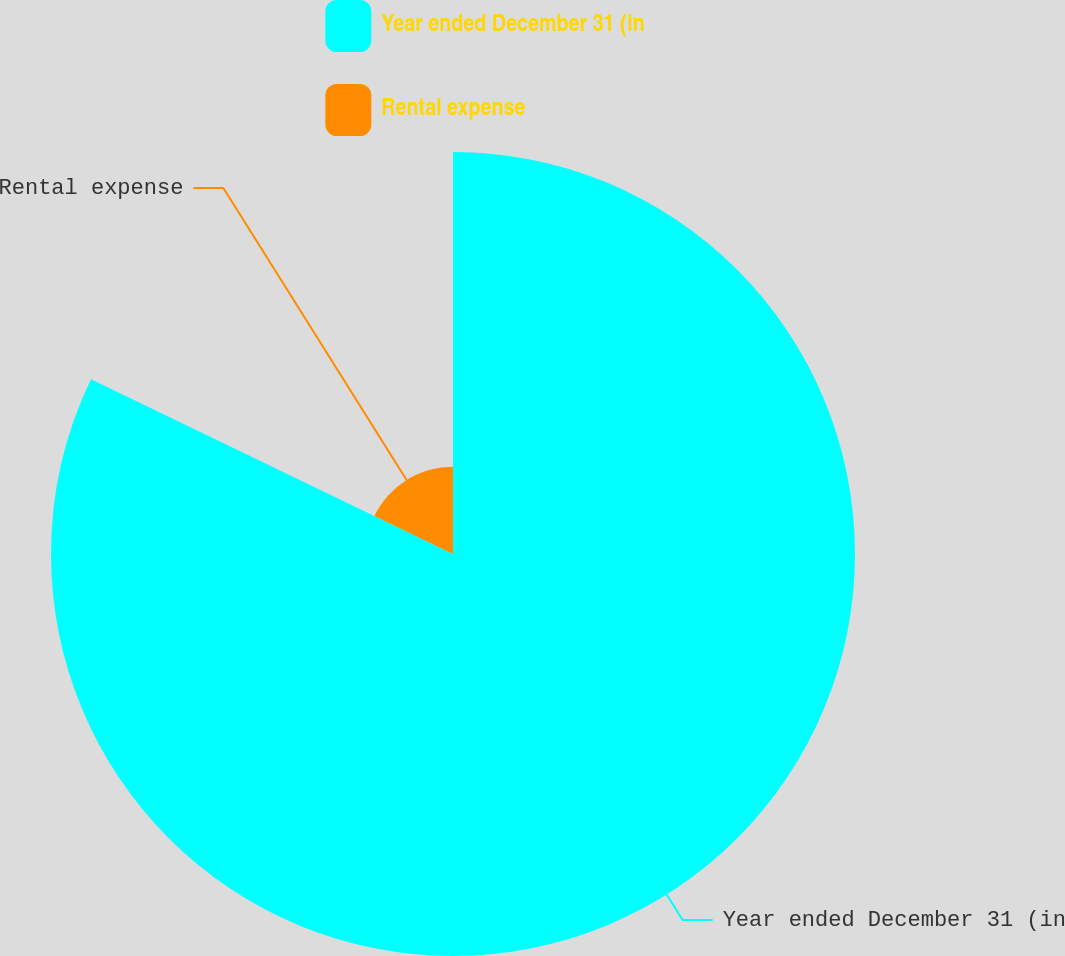Convert chart to OTSL. <chart><loc_0><loc_0><loc_500><loc_500><pie_chart><fcel>Year ended December 31 (in<fcel>Rental expense<nl><fcel>82.16%<fcel>17.84%<nl></chart> 